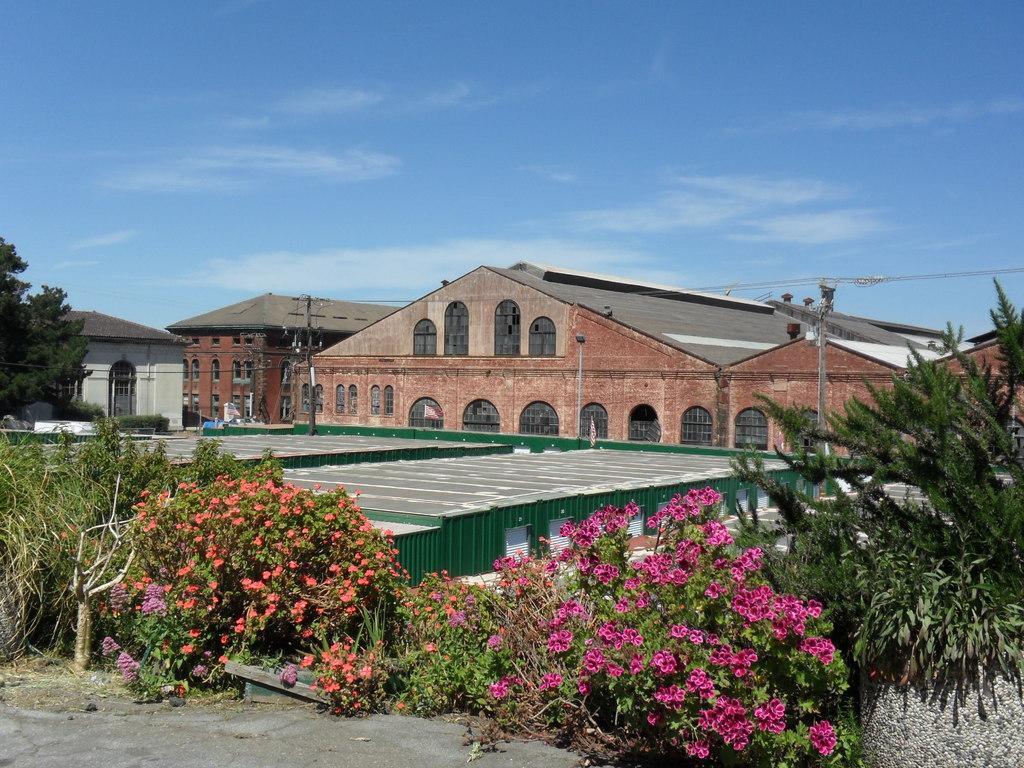Can you describe this image briefly? To the bottom of the image there are few plants with flowers in pink, orange and purple colors. Behind the plants there is a green room with roofs. And in the background there are buildings with roofs, windows with glass and walls. To the left corner of the image there is a tree. And to the top of the image there is a sky. 